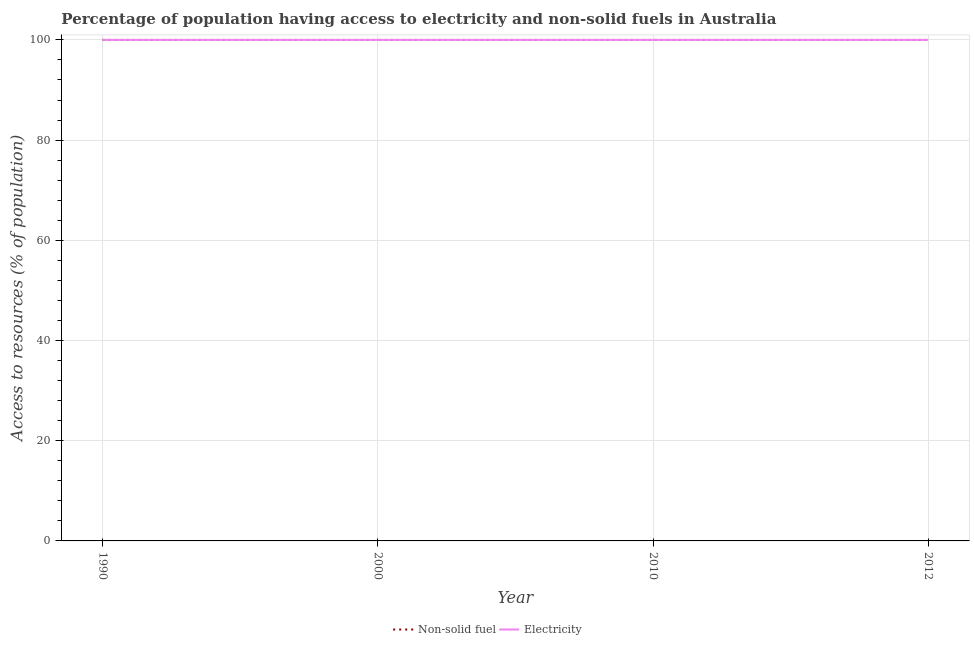Does the line corresponding to percentage of population having access to electricity intersect with the line corresponding to percentage of population having access to non-solid fuel?
Keep it short and to the point. Yes. Is the number of lines equal to the number of legend labels?
Offer a terse response. Yes. What is the percentage of population having access to electricity in 2000?
Provide a succinct answer. 100. Across all years, what is the maximum percentage of population having access to non-solid fuel?
Ensure brevity in your answer.  100. Across all years, what is the minimum percentage of population having access to non-solid fuel?
Your answer should be compact. 100. In which year was the percentage of population having access to non-solid fuel maximum?
Your response must be concise. 1990. In which year was the percentage of population having access to electricity minimum?
Offer a terse response. 1990. What is the total percentage of population having access to electricity in the graph?
Provide a succinct answer. 400. What is the difference between the percentage of population having access to electricity in 2000 and that in 2012?
Your response must be concise. 0. What is the difference between the percentage of population having access to electricity in 2000 and the percentage of population having access to non-solid fuel in 2012?
Offer a very short reply. 0. What is the average percentage of population having access to non-solid fuel per year?
Offer a terse response. 100. In the year 2012, what is the difference between the percentage of population having access to non-solid fuel and percentage of population having access to electricity?
Provide a short and direct response. 0. In how many years, is the percentage of population having access to non-solid fuel greater than 20 %?
Make the answer very short. 4. What is the ratio of the percentage of population having access to non-solid fuel in 2000 to that in 2010?
Give a very brief answer. 1. Is the percentage of population having access to non-solid fuel in 1990 less than that in 2012?
Your answer should be very brief. No. How many lines are there?
Make the answer very short. 2. What is the difference between two consecutive major ticks on the Y-axis?
Your answer should be very brief. 20. Are the values on the major ticks of Y-axis written in scientific E-notation?
Your answer should be very brief. No. Does the graph contain any zero values?
Provide a succinct answer. No. Does the graph contain grids?
Offer a very short reply. Yes. How are the legend labels stacked?
Provide a succinct answer. Horizontal. What is the title of the graph?
Your answer should be very brief. Percentage of population having access to electricity and non-solid fuels in Australia. Does "Nonresident" appear as one of the legend labels in the graph?
Give a very brief answer. No. What is the label or title of the Y-axis?
Your answer should be compact. Access to resources (% of population). What is the Access to resources (% of population) of Non-solid fuel in 1990?
Provide a succinct answer. 100. What is the Access to resources (% of population) of Non-solid fuel in 2000?
Provide a short and direct response. 100. What is the Access to resources (% of population) in Electricity in 2010?
Make the answer very short. 100. What is the Access to resources (% of population) of Non-solid fuel in 2012?
Provide a succinct answer. 100. Across all years, what is the maximum Access to resources (% of population) of Non-solid fuel?
Provide a short and direct response. 100. What is the total Access to resources (% of population) in Non-solid fuel in the graph?
Give a very brief answer. 400. What is the total Access to resources (% of population) in Electricity in the graph?
Give a very brief answer. 400. What is the difference between the Access to resources (% of population) in Non-solid fuel in 1990 and that in 2010?
Your answer should be very brief. 0. What is the difference between the Access to resources (% of population) in Non-solid fuel in 1990 and that in 2012?
Your response must be concise. 0. What is the difference between the Access to resources (% of population) of Electricity in 1990 and that in 2012?
Give a very brief answer. 0. What is the difference between the Access to resources (% of population) of Non-solid fuel in 2000 and that in 2010?
Provide a succinct answer. 0. What is the difference between the Access to resources (% of population) in Electricity in 2000 and that in 2010?
Your answer should be compact. 0. What is the difference between the Access to resources (% of population) of Electricity in 2010 and that in 2012?
Ensure brevity in your answer.  0. What is the difference between the Access to resources (% of population) in Non-solid fuel in 1990 and the Access to resources (% of population) in Electricity in 2000?
Make the answer very short. 0. What is the difference between the Access to resources (% of population) of Non-solid fuel in 1990 and the Access to resources (% of population) of Electricity in 2010?
Keep it short and to the point. 0. What is the difference between the Access to resources (% of population) in Non-solid fuel in 2000 and the Access to resources (% of population) in Electricity in 2012?
Offer a terse response. 0. What is the difference between the Access to resources (% of population) in Non-solid fuel in 2010 and the Access to resources (% of population) in Electricity in 2012?
Your answer should be compact. 0. What is the average Access to resources (% of population) of Electricity per year?
Provide a short and direct response. 100. In the year 1990, what is the difference between the Access to resources (% of population) in Non-solid fuel and Access to resources (% of population) in Electricity?
Keep it short and to the point. 0. What is the ratio of the Access to resources (% of population) in Non-solid fuel in 1990 to that in 2000?
Your answer should be very brief. 1. What is the ratio of the Access to resources (% of population) in Electricity in 1990 to that in 2000?
Ensure brevity in your answer.  1. What is the ratio of the Access to resources (% of population) of Electricity in 1990 to that in 2010?
Your response must be concise. 1. What is the ratio of the Access to resources (% of population) in Electricity in 1990 to that in 2012?
Provide a succinct answer. 1. What is the ratio of the Access to resources (% of population) of Electricity in 2000 to that in 2010?
Your answer should be compact. 1. What is the ratio of the Access to resources (% of population) in Electricity in 2000 to that in 2012?
Your answer should be very brief. 1. What is the ratio of the Access to resources (% of population) in Non-solid fuel in 2010 to that in 2012?
Your answer should be compact. 1. What is the ratio of the Access to resources (% of population) in Electricity in 2010 to that in 2012?
Keep it short and to the point. 1. What is the difference between the highest and the second highest Access to resources (% of population) in Non-solid fuel?
Provide a short and direct response. 0. What is the difference between the highest and the second highest Access to resources (% of population) of Electricity?
Ensure brevity in your answer.  0. 